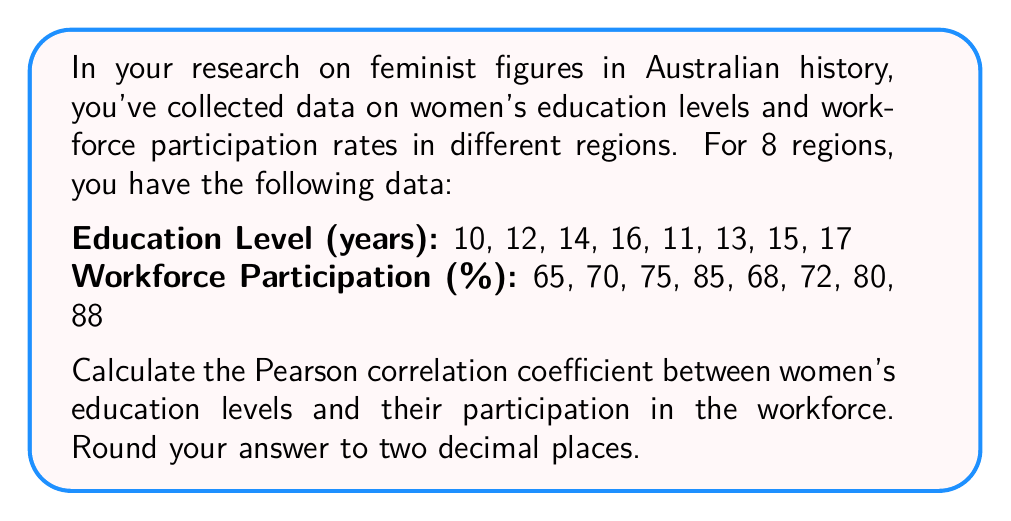Give your solution to this math problem. To calculate the Pearson correlation coefficient, we'll follow these steps:

1. Calculate the means of X (education level) and Y (workforce participation):
   $\bar{X} = \frac{10+12+14+16+11+13+15+17}{8} = 13.5$
   $\bar{Y} = \frac{65+70+75+85+68+72+80+88}{8} = 75.375$

2. Calculate the deviations from the mean for both X and Y:
   X deviations: -3.5, -1.5, 0.5, 2.5, -2.5, -0.5, 1.5, 3.5
   Y deviations: -10.375, -5.375, -0.375, 9.625, -7.375, -3.375, 4.625, 12.625

3. Calculate the products of these deviations:
   36.3125, 8.0625, -0.1875, 24.0625, 18.4375, 1.6875, 6.9375, 44.1875

4. Sum the products of deviations:
   $\sum_{i=1}^{n} (x_i - \bar{X})(y_i - \bar{Y}) = 139.5$

5. Calculate the sum of squared deviations for X and Y:
   $\sum_{i=1}^{n} (x_i - \bar{X})^2 = 56$
   $\sum_{i=1}^{n} (y_i - \bar{Y})^2 = 548.9375$

6. Apply the Pearson correlation coefficient formula:
   $$r = \frac{\sum_{i=1}^{n} (x_i - \bar{X})(y_i - \bar{Y})}{\sqrt{\sum_{i=1}^{n} (x_i - \bar{X})^2 \sum_{i=1}^{n} (y_i - \bar{Y})^2}}$$

   $$r = \frac{139.5}{\sqrt{56 \times 548.9375}} = \frac{139.5}{175.2831} \approx 0.7958$$

7. Round to two decimal places: 0.80
Answer: 0.80 